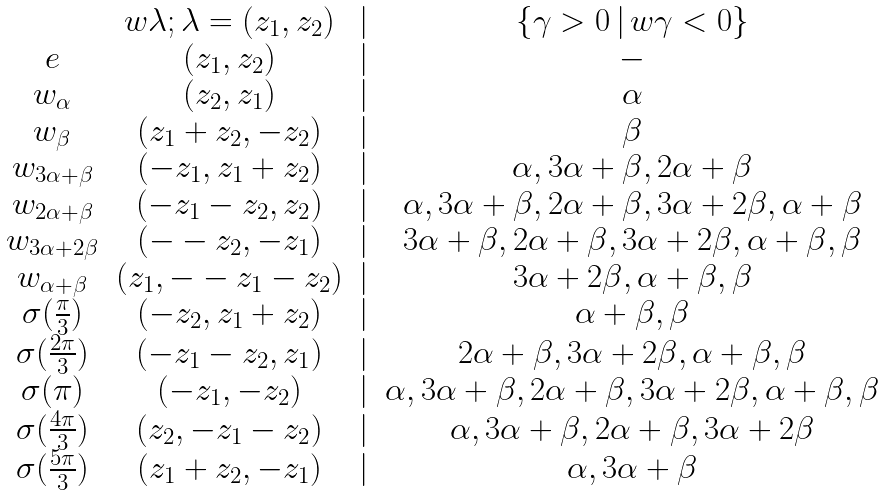Convert formula to latex. <formula><loc_0><loc_0><loc_500><loc_500>\begin{matrix} & w \lambda ; \lambda = ( z _ { 1 } , z _ { 2 } ) & | & \{ \gamma > 0 \, | \, w \gamma < 0 \} \\ e & ( z _ { 1 } , z _ { 2 } ) & | & - \\ w _ { \alpha } & ( z _ { 2 } , z _ { 1 } ) & | & \alpha \\ w _ { \beta } & ( z _ { 1 } + z _ { 2 } , - z _ { 2 } ) & | & \beta \\ w _ { 3 \alpha + \beta } & ( - z _ { 1 } , z _ { 1 } + z _ { 2 } ) & | & \alpha , 3 \alpha + \beta , 2 \alpha + \beta \\ w _ { 2 \alpha + \beta } & ( - z _ { 1 } - z _ { 2 } , z _ { 2 } ) & | & \alpha , 3 \alpha + \beta , 2 \alpha + \beta , 3 \alpha + 2 \beta , \alpha + \beta \\ w _ { 3 \alpha + 2 \beta } & ( - - z _ { 2 } , - z _ { 1 } ) & | & 3 \alpha + \beta , 2 \alpha + \beta , 3 \alpha + 2 \beta , \alpha + \beta , \beta \\ w _ { \alpha + \beta } & ( z _ { 1 } , - - z _ { 1 } - z _ { 2 } ) & | & 3 \alpha + 2 \beta , \alpha + \beta , \beta \\ \sigma ( \frac { \pi } { 3 } ) & ( - z _ { 2 } , z _ { 1 } + z _ { 2 } ) & | & \alpha + \beta , \beta \\ \sigma ( \frac { 2 \pi } { 3 } ) & ( - z _ { 1 } - z _ { 2 } , z _ { 1 } ) & | & 2 \alpha + \beta , 3 \alpha + 2 \beta , \alpha + \beta , \beta \\ \sigma ( \pi ) & ( - z _ { 1 } , - z _ { 2 } ) & | & \alpha , 3 \alpha + \beta , 2 \alpha + \beta , 3 \alpha + 2 \beta , \alpha + \beta , \beta \\ \sigma ( \frac { 4 \pi } { 3 } ) & ( z _ { 2 } , - z _ { 1 } - z _ { 2 } ) & | & \alpha , 3 \alpha + \beta , 2 \alpha + \beta , 3 \alpha + 2 \beta \\ \sigma ( \frac { 5 \pi } { 3 } ) & ( z _ { 1 } + z _ { 2 } , - z _ { 1 } ) & | & \alpha , 3 \alpha + \beta \end{matrix}</formula> 